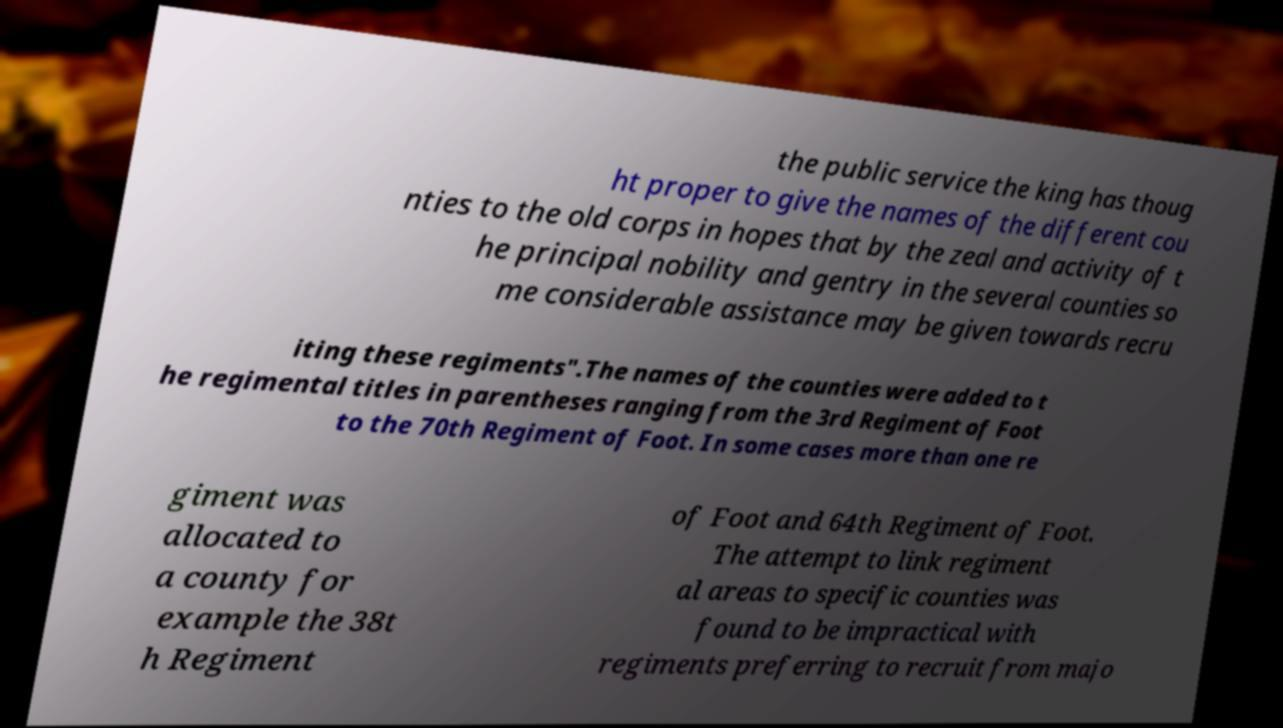There's text embedded in this image that I need extracted. Can you transcribe it verbatim? the public service the king has thoug ht proper to give the names of the different cou nties to the old corps in hopes that by the zeal and activity of t he principal nobility and gentry in the several counties so me considerable assistance may be given towards recru iting these regiments".The names of the counties were added to t he regimental titles in parentheses ranging from the 3rd Regiment of Foot to the 70th Regiment of Foot. In some cases more than one re giment was allocated to a county for example the 38t h Regiment of Foot and 64th Regiment of Foot. The attempt to link regiment al areas to specific counties was found to be impractical with regiments preferring to recruit from majo 